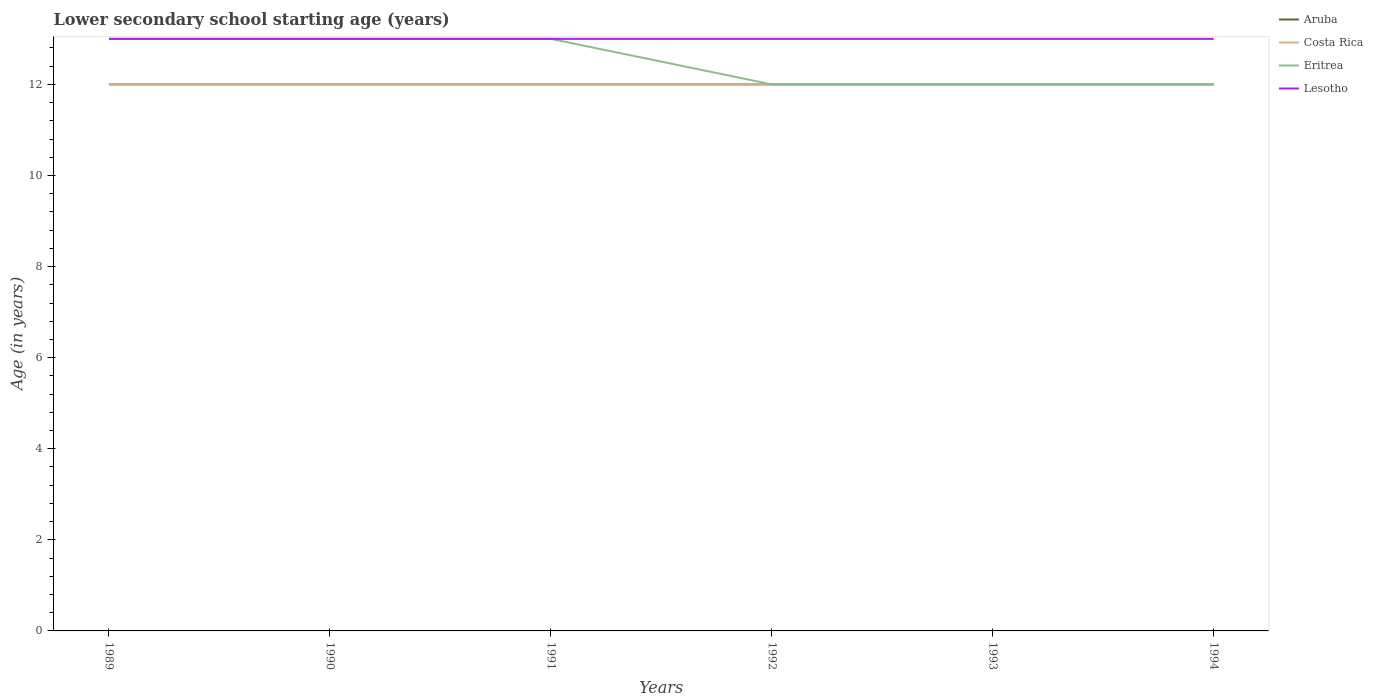How many different coloured lines are there?
Offer a very short reply. 4. Does the line corresponding to Lesotho intersect with the line corresponding to Eritrea?
Offer a very short reply. Yes. Across all years, what is the maximum lower secondary school starting age of children in Lesotho?
Ensure brevity in your answer.  13. What is the total lower secondary school starting age of children in Costa Rica in the graph?
Keep it short and to the point. 0. What is the difference between the highest and the lowest lower secondary school starting age of children in Lesotho?
Provide a short and direct response. 0. Is the lower secondary school starting age of children in Lesotho strictly greater than the lower secondary school starting age of children in Costa Rica over the years?
Make the answer very short. No. How many lines are there?
Keep it short and to the point. 4. How many years are there in the graph?
Your response must be concise. 6. Does the graph contain any zero values?
Your response must be concise. No. Does the graph contain grids?
Give a very brief answer. No. How are the legend labels stacked?
Your answer should be compact. Vertical. What is the title of the graph?
Ensure brevity in your answer.  Lower secondary school starting age (years). What is the label or title of the X-axis?
Provide a short and direct response. Years. What is the label or title of the Y-axis?
Your response must be concise. Age (in years). What is the Age (in years) of Lesotho in 1989?
Your answer should be compact. 13. What is the Age (in years) in Aruba in 1990?
Give a very brief answer. 12. What is the Age (in years) of Costa Rica in 1990?
Ensure brevity in your answer.  12. What is the Age (in years) in Eritrea in 1990?
Your answer should be very brief. 13. What is the Age (in years) in Lesotho in 1990?
Make the answer very short. 13. What is the Age (in years) in Aruba in 1991?
Provide a succinct answer. 12. What is the Age (in years) in Costa Rica in 1991?
Provide a short and direct response. 12. What is the Age (in years) in Lesotho in 1991?
Provide a short and direct response. 13. What is the Age (in years) of Aruba in 1992?
Keep it short and to the point. 12. What is the Age (in years) in Lesotho in 1992?
Ensure brevity in your answer.  13. What is the Age (in years) in Aruba in 1993?
Keep it short and to the point. 12. What is the Age (in years) of Costa Rica in 1993?
Keep it short and to the point. 12. What is the Age (in years) of Costa Rica in 1994?
Offer a terse response. 12. What is the Age (in years) of Eritrea in 1994?
Keep it short and to the point. 12. Across all years, what is the maximum Age (in years) of Aruba?
Offer a very short reply. 12. Across all years, what is the maximum Age (in years) in Costa Rica?
Offer a terse response. 12. Across all years, what is the minimum Age (in years) in Costa Rica?
Make the answer very short. 12. What is the difference between the Age (in years) in Aruba in 1989 and that in 1990?
Your response must be concise. 0. What is the difference between the Age (in years) of Eritrea in 1989 and that in 1990?
Offer a terse response. 0. What is the difference between the Age (in years) in Eritrea in 1989 and that in 1991?
Your answer should be compact. 0. What is the difference between the Age (in years) in Lesotho in 1989 and that in 1991?
Make the answer very short. 0. What is the difference between the Age (in years) of Aruba in 1989 and that in 1992?
Your response must be concise. 0. What is the difference between the Age (in years) of Lesotho in 1989 and that in 1992?
Your answer should be compact. 0. What is the difference between the Age (in years) of Costa Rica in 1989 and that in 1994?
Offer a terse response. 0. What is the difference between the Age (in years) in Eritrea in 1989 and that in 1994?
Give a very brief answer. 1. What is the difference between the Age (in years) of Aruba in 1990 and that in 1991?
Your answer should be very brief. 0. What is the difference between the Age (in years) in Costa Rica in 1990 and that in 1991?
Your answer should be very brief. 0. What is the difference between the Age (in years) in Eritrea in 1990 and that in 1991?
Give a very brief answer. 0. What is the difference between the Age (in years) of Costa Rica in 1990 and that in 1992?
Ensure brevity in your answer.  0. What is the difference between the Age (in years) of Eritrea in 1990 and that in 1992?
Provide a short and direct response. 1. What is the difference between the Age (in years) in Eritrea in 1990 and that in 1993?
Your answer should be very brief. 1. What is the difference between the Age (in years) in Lesotho in 1990 and that in 1993?
Provide a succinct answer. 0. What is the difference between the Age (in years) in Aruba in 1990 and that in 1994?
Provide a succinct answer. 0. What is the difference between the Age (in years) in Costa Rica in 1990 and that in 1994?
Your response must be concise. 0. What is the difference between the Age (in years) of Lesotho in 1990 and that in 1994?
Ensure brevity in your answer.  0. What is the difference between the Age (in years) of Aruba in 1991 and that in 1992?
Your answer should be very brief. 0. What is the difference between the Age (in years) in Lesotho in 1991 and that in 1992?
Give a very brief answer. 0. What is the difference between the Age (in years) of Aruba in 1991 and that in 1994?
Your answer should be compact. 0. What is the difference between the Age (in years) of Eritrea in 1991 and that in 1994?
Provide a succinct answer. 1. What is the difference between the Age (in years) in Lesotho in 1991 and that in 1994?
Your answer should be compact. 0. What is the difference between the Age (in years) of Aruba in 1992 and that in 1993?
Provide a short and direct response. 0. What is the difference between the Age (in years) of Costa Rica in 1992 and that in 1993?
Keep it short and to the point. 0. What is the difference between the Age (in years) of Aruba in 1992 and that in 1994?
Provide a short and direct response. 0. What is the difference between the Age (in years) in Costa Rica in 1992 and that in 1994?
Your answer should be compact. 0. What is the difference between the Age (in years) in Lesotho in 1992 and that in 1994?
Offer a very short reply. 0. What is the difference between the Age (in years) of Lesotho in 1993 and that in 1994?
Offer a terse response. 0. What is the difference between the Age (in years) of Aruba in 1989 and the Age (in years) of Costa Rica in 1990?
Your answer should be very brief. 0. What is the difference between the Age (in years) in Aruba in 1989 and the Age (in years) in Eritrea in 1990?
Give a very brief answer. -1. What is the difference between the Age (in years) in Costa Rica in 1989 and the Age (in years) in Eritrea in 1990?
Provide a succinct answer. -1. What is the difference between the Age (in years) in Eritrea in 1989 and the Age (in years) in Lesotho in 1990?
Keep it short and to the point. 0. What is the difference between the Age (in years) in Aruba in 1989 and the Age (in years) in Costa Rica in 1991?
Provide a succinct answer. 0. What is the difference between the Age (in years) of Aruba in 1989 and the Age (in years) of Eritrea in 1991?
Offer a terse response. -1. What is the difference between the Age (in years) in Eritrea in 1989 and the Age (in years) in Lesotho in 1991?
Ensure brevity in your answer.  0. What is the difference between the Age (in years) of Aruba in 1989 and the Age (in years) of Costa Rica in 1992?
Your answer should be compact. 0. What is the difference between the Age (in years) in Aruba in 1989 and the Age (in years) in Eritrea in 1992?
Make the answer very short. 0. What is the difference between the Age (in years) of Aruba in 1989 and the Age (in years) of Costa Rica in 1993?
Your answer should be compact. 0. What is the difference between the Age (in years) of Aruba in 1989 and the Age (in years) of Eritrea in 1993?
Your answer should be very brief. 0. What is the difference between the Age (in years) of Aruba in 1989 and the Age (in years) of Lesotho in 1993?
Offer a very short reply. -1. What is the difference between the Age (in years) of Eritrea in 1989 and the Age (in years) of Lesotho in 1993?
Ensure brevity in your answer.  0. What is the difference between the Age (in years) in Aruba in 1989 and the Age (in years) in Eritrea in 1994?
Offer a very short reply. 0. What is the difference between the Age (in years) in Costa Rica in 1989 and the Age (in years) in Eritrea in 1994?
Provide a succinct answer. 0. What is the difference between the Age (in years) in Costa Rica in 1989 and the Age (in years) in Lesotho in 1994?
Provide a short and direct response. -1. What is the difference between the Age (in years) of Eritrea in 1989 and the Age (in years) of Lesotho in 1994?
Make the answer very short. 0. What is the difference between the Age (in years) of Aruba in 1990 and the Age (in years) of Eritrea in 1991?
Keep it short and to the point. -1. What is the difference between the Age (in years) in Aruba in 1990 and the Age (in years) in Lesotho in 1991?
Offer a very short reply. -1. What is the difference between the Age (in years) of Costa Rica in 1990 and the Age (in years) of Eritrea in 1991?
Your answer should be compact. -1. What is the difference between the Age (in years) of Costa Rica in 1990 and the Age (in years) of Lesotho in 1991?
Your answer should be very brief. -1. What is the difference between the Age (in years) of Aruba in 1990 and the Age (in years) of Eritrea in 1992?
Offer a terse response. 0. What is the difference between the Age (in years) of Eritrea in 1990 and the Age (in years) of Lesotho in 1992?
Provide a succinct answer. 0. What is the difference between the Age (in years) in Aruba in 1990 and the Age (in years) in Eritrea in 1993?
Offer a very short reply. 0. What is the difference between the Age (in years) of Costa Rica in 1990 and the Age (in years) of Eritrea in 1993?
Your answer should be very brief. 0. What is the difference between the Age (in years) of Eritrea in 1990 and the Age (in years) of Lesotho in 1993?
Ensure brevity in your answer.  0. What is the difference between the Age (in years) in Aruba in 1990 and the Age (in years) in Costa Rica in 1994?
Your answer should be compact. 0. What is the difference between the Age (in years) of Aruba in 1990 and the Age (in years) of Eritrea in 1994?
Your answer should be compact. 0. What is the difference between the Age (in years) in Aruba in 1990 and the Age (in years) in Lesotho in 1994?
Your answer should be compact. -1. What is the difference between the Age (in years) of Costa Rica in 1990 and the Age (in years) of Eritrea in 1994?
Keep it short and to the point. 0. What is the difference between the Age (in years) in Costa Rica in 1990 and the Age (in years) in Lesotho in 1994?
Provide a short and direct response. -1. What is the difference between the Age (in years) in Costa Rica in 1991 and the Age (in years) in Lesotho in 1992?
Provide a succinct answer. -1. What is the difference between the Age (in years) of Eritrea in 1991 and the Age (in years) of Lesotho in 1992?
Offer a very short reply. 0. What is the difference between the Age (in years) in Aruba in 1991 and the Age (in years) in Costa Rica in 1993?
Your response must be concise. 0. What is the difference between the Age (in years) in Aruba in 1991 and the Age (in years) in Eritrea in 1993?
Give a very brief answer. 0. What is the difference between the Age (in years) in Aruba in 1991 and the Age (in years) in Lesotho in 1993?
Your answer should be very brief. -1. What is the difference between the Age (in years) in Costa Rica in 1991 and the Age (in years) in Eritrea in 1993?
Offer a very short reply. 0. What is the difference between the Age (in years) of Costa Rica in 1991 and the Age (in years) of Lesotho in 1993?
Provide a succinct answer. -1. What is the difference between the Age (in years) of Eritrea in 1991 and the Age (in years) of Lesotho in 1993?
Make the answer very short. 0. What is the difference between the Age (in years) in Aruba in 1991 and the Age (in years) in Eritrea in 1994?
Provide a short and direct response. 0. What is the difference between the Age (in years) in Aruba in 1991 and the Age (in years) in Lesotho in 1994?
Your answer should be compact. -1. What is the difference between the Age (in years) in Aruba in 1992 and the Age (in years) in Costa Rica in 1993?
Provide a short and direct response. 0. What is the difference between the Age (in years) in Aruba in 1992 and the Age (in years) in Lesotho in 1993?
Give a very brief answer. -1. What is the difference between the Age (in years) in Costa Rica in 1992 and the Age (in years) in Eritrea in 1993?
Give a very brief answer. 0. What is the difference between the Age (in years) of Eritrea in 1992 and the Age (in years) of Lesotho in 1993?
Provide a succinct answer. -1. What is the difference between the Age (in years) of Eritrea in 1992 and the Age (in years) of Lesotho in 1994?
Provide a short and direct response. -1. What is the difference between the Age (in years) of Aruba in 1993 and the Age (in years) of Costa Rica in 1994?
Your answer should be very brief. 0. What is the difference between the Age (in years) in Costa Rica in 1993 and the Age (in years) in Lesotho in 1994?
Ensure brevity in your answer.  -1. What is the difference between the Age (in years) in Eritrea in 1993 and the Age (in years) in Lesotho in 1994?
Keep it short and to the point. -1. What is the average Age (in years) of Costa Rica per year?
Make the answer very short. 12. What is the average Age (in years) of Eritrea per year?
Provide a short and direct response. 12.5. What is the average Age (in years) of Lesotho per year?
Your answer should be compact. 13. In the year 1989, what is the difference between the Age (in years) of Aruba and Age (in years) of Costa Rica?
Offer a terse response. 0. In the year 1989, what is the difference between the Age (in years) of Aruba and Age (in years) of Lesotho?
Your response must be concise. -1. In the year 1989, what is the difference between the Age (in years) of Costa Rica and Age (in years) of Lesotho?
Provide a short and direct response. -1. In the year 1989, what is the difference between the Age (in years) of Eritrea and Age (in years) of Lesotho?
Provide a short and direct response. 0. In the year 1990, what is the difference between the Age (in years) in Aruba and Age (in years) in Eritrea?
Keep it short and to the point. -1. In the year 1990, what is the difference between the Age (in years) of Costa Rica and Age (in years) of Eritrea?
Keep it short and to the point. -1. In the year 1991, what is the difference between the Age (in years) of Aruba and Age (in years) of Eritrea?
Provide a short and direct response. -1. In the year 1991, what is the difference between the Age (in years) of Costa Rica and Age (in years) of Eritrea?
Keep it short and to the point. -1. In the year 1991, what is the difference between the Age (in years) in Costa Rica and Age (in years) in Lesotho?
Offer a terse response. -1. In the year 1992, what is the difference between the Age (in years) in Aruba and Age (in years) in Eritrea?
Provide a succinct answer. 0. In the year 1992, what is the difference between the Age (in years) in Aruba and Age (in years) in Lesotho?
Make the answer very short. -1. In the year 1993, what is the difference between the Age (in years) of Aruba and Age (in years) of Costa Rica?
Your response must be concise. 0. In the year 1993, what is the difference between the Age (in years) in Costa Rica and Age (in years) in Lesotho?
Your answer should be very brief. -1. In the year 1993, what is the difference between the Age (in years) in Eritrea and Age (in years) in Lesotho?
Provide a succinct answer. -1. In the year 1994, what is the difference between the Age (in years) in Aruba and Age (in years) in Eritrea?
Give a very brief answer. 0. In the year 1994, what is the difference between the Age (in years) of Costa Rica and Age (in years) of Lesotho?
Provide a succinct answer. -1. In the year 1994, what is the difference between the Age (in years) in Eritrea and Age (in years) in Lesotho?
Provide a short and direct response. -1. What is the ratio of the Age (in years) in Eritrea in 1989 to that in 1990?
Give a very brief answer. 1. What is the ratio of the Age (in years) of Aruba in 1989 to that in 1991?
Keep it short and to the point. 1. What is the ratio of the Age (in years) of Eritrea in 1989 to that in 1991?
Provide a short and direct response. 1. What is the ratio of the Age (in years) in Lesotho in 1989 to that in 1991?
Your answer should be compact. 1. What is the ratio of the Age (in years) in Aruba in 1989 to that in 1992?
Keep it short and to the point. 1. What is the ratio of the Age (in years) of Costa Rica in 1989 to that in 1992?
Ensure brevity in your answer.  1. What is the ratio of the Age (in years) of Lesotho in 1989 to that in 1992?
Your answer should be very brief. 1. What is the ratio of the Age (in years) in Aruba in 1989 to that in 1993?
Offer a terse response. 1. What is the ratio of the Age (in years) in Aruba in 1989 to that in 1994?
Provide a succinct answer. 1. What is the ratio of the Age (in years) in Eritrea in 1989 to that in 1994?
Provide a succinct answer. 1.08. What is the ratio of the Age (in years) of Lesotho in 1989 to that in 1994?
Keep it short and to the point. 1. What is the ratio of the Age (in years) in Costa Rica in 1990 to that in 1991?
Offer a very short reply. 1. What is the ratio of the Age (in years) in Lesotho in 1990 to that in 1992?
Ensure brevity in your answer.  1. What is the ratio of the Age (in years) of Aruba in 1990 to that in 1993?
Provide a short and direct response. 1. What is the ratio of the Age (in years) of Costa Rica in 1990 to that in 1993?
Provide a succinct answer. 1. What is the ratio of the Age (in years) in Eritrea in 1990 to that in 1993?
Your response must be concise. 1.08. What is the ratio of the Age (in years) in Eritrea in 1990 to that in 1994?
Provide a succinct answer. 1.08. What is the ratio of the Age (in years) in Lesotho in 1990 to that in 1994?
Your response must be concise. 1. What is the ratio of the Age (in years) of Lesotho in 1991 to that in 1992?
Ensure brevity in your answer.  1. What is the ratio of the Age (in years) in Aruba in 1991 to that in 1994?
Make the answer very short. 1. What is the ratio of the Age (in years) of Eritrea in 1992 to that in 1993?
Make the answer very short. 1. What is the ratio of the Age (in years) of Lesotho in 1992 to that in 1993?
Your answer should be very brief. 1. What is the ratio of the Age (in years) of Aruba in 1993 to that in 1994?
Offer a very short reply. 1. What is the ratio of the Age (in years) of Costa Rica in 1993 to that in 1994?
Provide a succinct answer. 1. What is the ratio of the Age (in years) in Eritrea in 1993 to that in 1994?
Make the answer very short. 1. What is the difference between the highest and the second highest Age (in years) of Aruba?
Keep it short and to the point. 0. What is the difference between the highest and the second highest Age (in years) in Lesotho?
Offer a terse response. 0. What is the difference between the highest and the lowest Age (in years) of Aruba?
Provide a short and direct response. 0. What is the difference between the highest and the lowest Age (in years) of Lesotho?
Make the answer very short. 0. 